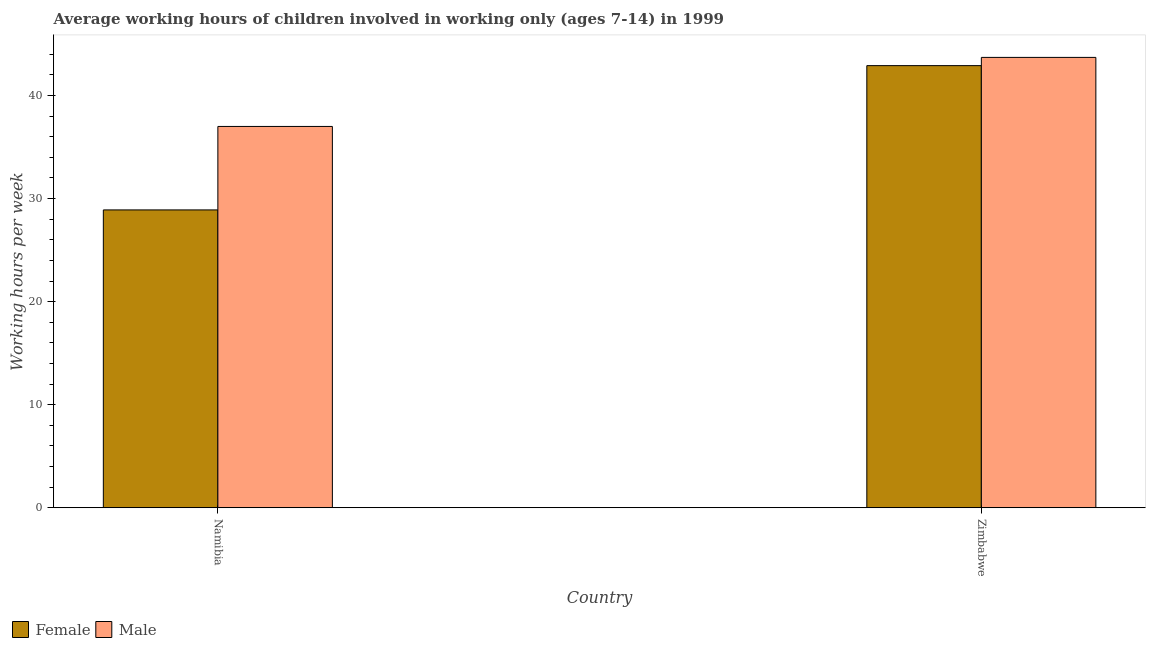How many groups of bars are there?
Provide a succinct answer. 2. Are the number of bars on each tick of the X-axis equal?
Offer a terse response. Yes. How many bars are there on the 1st tick from the left?
Your answer should be compact. 2. How many bars are there on the 1st tick from the right?
Ensure brevity in your answer.  2. What is the label of the 1st group of bars from the left?
Provide a succinct answer. Namibia. In how many cases, is the number of bars for a given country not equal to the number of legend labels?
Ensure brevity in your answer.  0. What is the average working hour of female children in Namibia?
Ensure brevity in your answer.  28.9. Across all countries, what is the maximum average working hour of female children?
Your answer should be very brief. 42.9. Across all countries, what is the minimum average working hour of female children?
Offer a very short reply. 28.9. In which country was the average working hour of female children maximum?
Your response must be concise. Zimbabwe. In which country was the average working hour of male children minimum?
Provide a succinct answer. Namibia. What is the total average working hour of male children in the graph?
Provide a succinct answer. 80.7. What is the difference between the average working hour of male children in Namibia and that in Zimbabwe?
Give a very brief answer. -6.7. What is the difference between the average working hour of female children in Zimbabwe and the average working hour of male children in Namibia?
Provide a short and direct response. 5.9. What is the average average working hour of female children per country?
Provide a succinct answer. 35.9. What is the difference between the average working hour of male children and average working hour of female children in Zimbabwe?
Your answer should be very brief. 0.8. What is the ratio of the average working hour of male children in Namibia to that in Zimbabwe?
Ensure brevity in your answer.  0.85. In how many countries, is the average working hour of female children greater than the average average working hour of female children taken over all countries?
Keep it short and to the point. 1. What does the 1st bar from the right in Zimbabwe represents?
Provide a succinct answer. Male. Are the values on the major ticks of Y-axis written in scientific E-notation?
Keep it short and to the point. No. Does the graph contain any zero values?
Your answer should be very brief. No. Does the graph contain grids?
Make the answer very short. No. How are the legend labels stacked?
Ensure brevity in your answer.  Horizontal. What is the title of the graph?
Offer a terse response. Average working hours of children involved in working only (ages 7-14) in 1999. Does "Exports" appear as one of the legend labels in the graph?
Your answer should be very brief. No. What is the label or title of the Y-axis?
Your response must be concise. Working hours per week. What is the Working hours per week in Female in Namibia?
Keep it short and to the point. 28.9. What is the Working hours per week in Female in Zimbabwe?
Ensure brevity in your answer.  42.9. What is the Working hours per week in Male in Zimbabwe?
Ensure brevity in your answer.  43.7. Across all countries, what is the maximum Working hours per week in Female?
Provide a succinct answer. 42.9. Across all countries, what is the maximum Working hours per week in Male?
Make the answer very short. 43.7. Across all countries, what is the minimum Working hours per week in Female?
Your answer should be compact. 28.9. Across all countries, what is the minimum Working hours per week in Male?
Provide a succinct answer. 37. What is the total Working hours per week in Female in the graph?
Your answer should be compact. 71.8. What is the total Working hours per week of Male in the graph?
Provide a succinct answer. 80.7. What is the difference between the Working hours per week in Female in Namibia and the Working hours per week in Male in Zimbabwe?
Your answer should be very brief. -14.8. What is the average Working hours per week of Female per country?
Give a very brief answer. 35.9. What is the average Working hours per week in Male per country?
Offer a very short reply. 40.35. What is the difference between the Working hours per week of Female and Working hours per week of Male in Zimbabwe?
Give a very brief answer. -0.8. What is the ratio of the Working hours per week of Female in Namibia to that in Zimbabwe?
Offer a terse response. 0.67. What is the ratio of the Working hours per week in Male in Namibia to that in Zimbabwe?
Provide a short and direct response. 0.85. What is the difference between the highest and the second highest Working hours per week of Female?
Provide a succinct answer. 14. What is the difference between the highest and the lowest Working hours per week of Female?
Your answer should be compact. 14. 